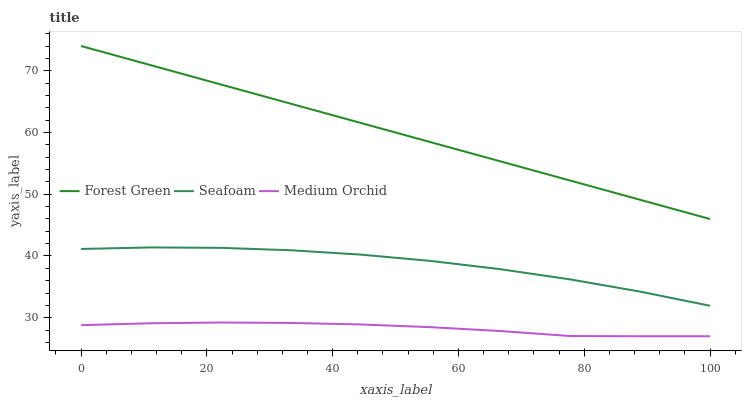Does Medium Orchid have the minimum area under the curve?
Answer yes or no. Yes. Does Seafoam have the minimum area under the curve?
Answer yes or no. No. Does Seafoam have the maximum area under the curve?
Answer yes or no. No. Is Medium Orchid the smoothest?
Answer yes or no. No. Is Medium Orchid the roughest?
Answer yes or no. No. Does Seafoam have the lowest value?
Answer yes or no. No. Does Seafoam have the highest value?
Answer yes or no. No. Is Medium Orchid less than Seafoam?
Answer yes or no. Yes. Is Forest Green greater than Seafoam?
Answer yes or no. Yes. Does Medium Orchid intersect Seafoam?
Answer yes or no. No. 